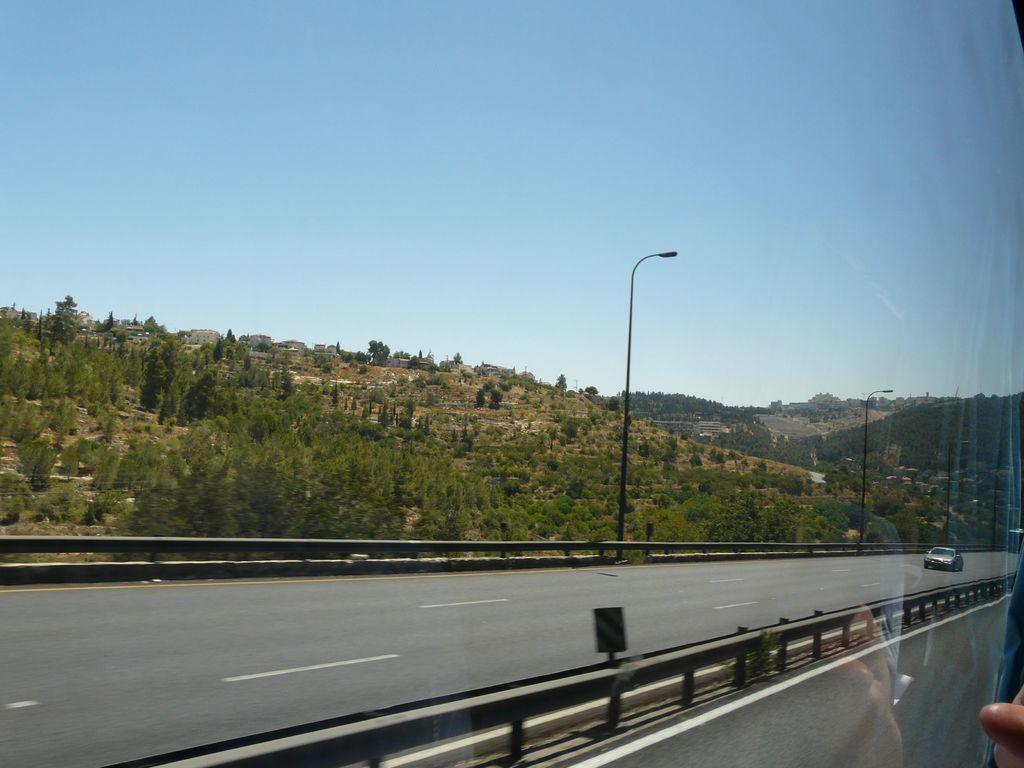Can you describe this image briefly? In this picture we can see a glass in the front, on the right side there is a car traveling on the road, in the background we can see trees, poles and lights, there is the sky at the top of the picture, at the right bottom there is a person's finger. 